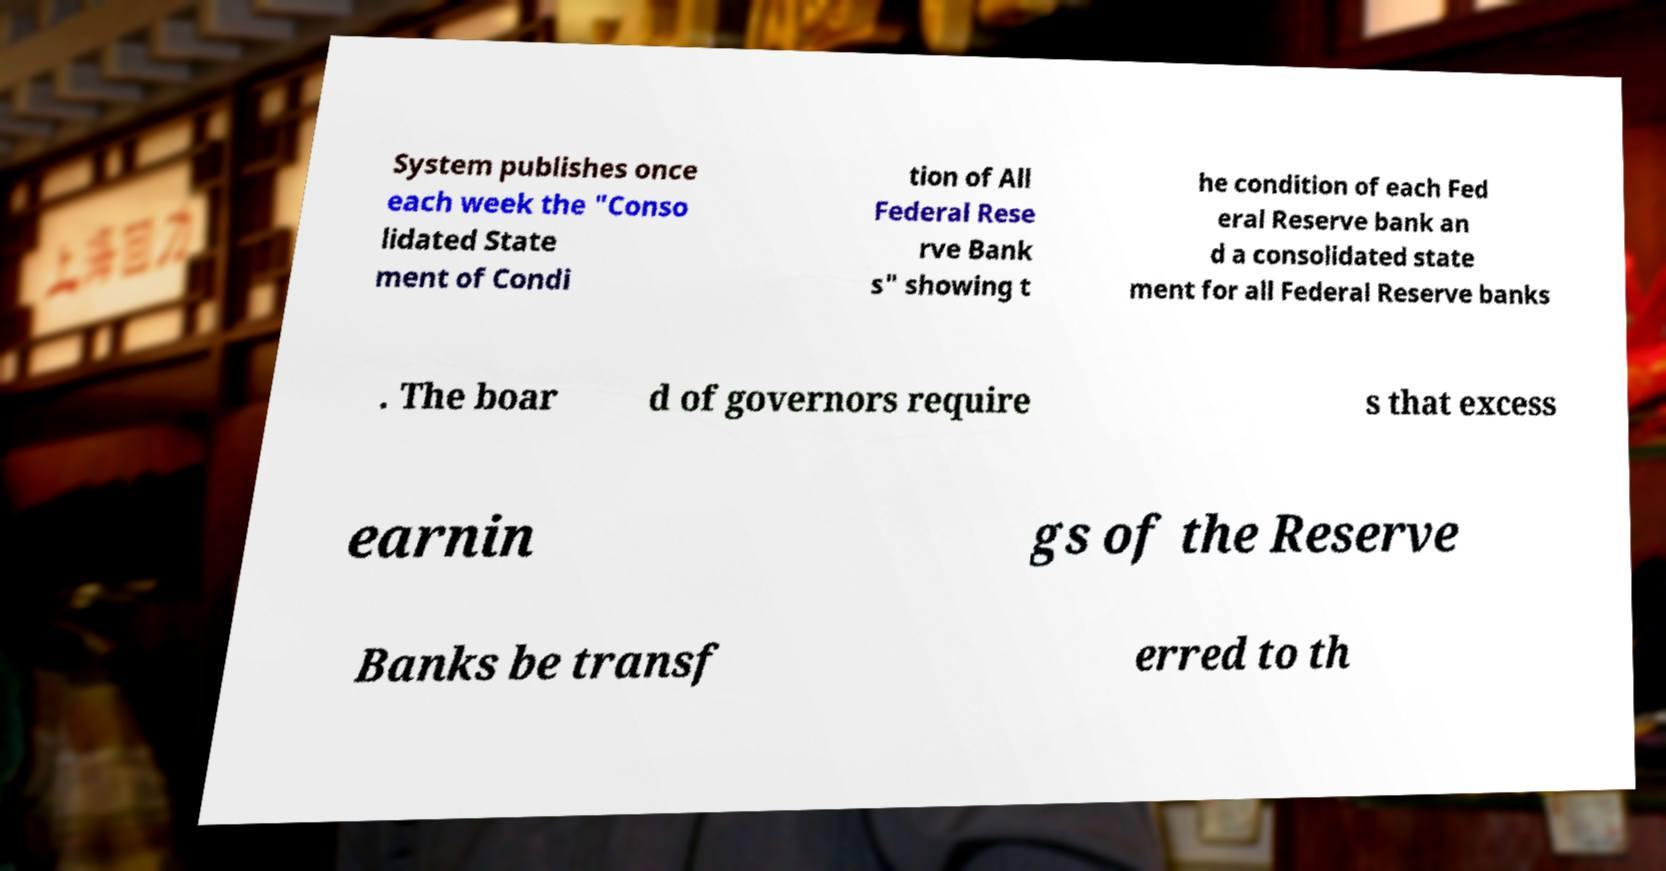What messages or text are displayed in this image? I need them in a readable, typed format. System publishes once each week the "Conso lidated State ment of Condi tion of All Federal Rese rve Bank s" showing t he condition of each Fed eral Reserve bank an d a consolidated state ment for all Federal Reserve banks . The boar d of governors require s that excess earnin gs of the Reserve Banks be transf erred to th 